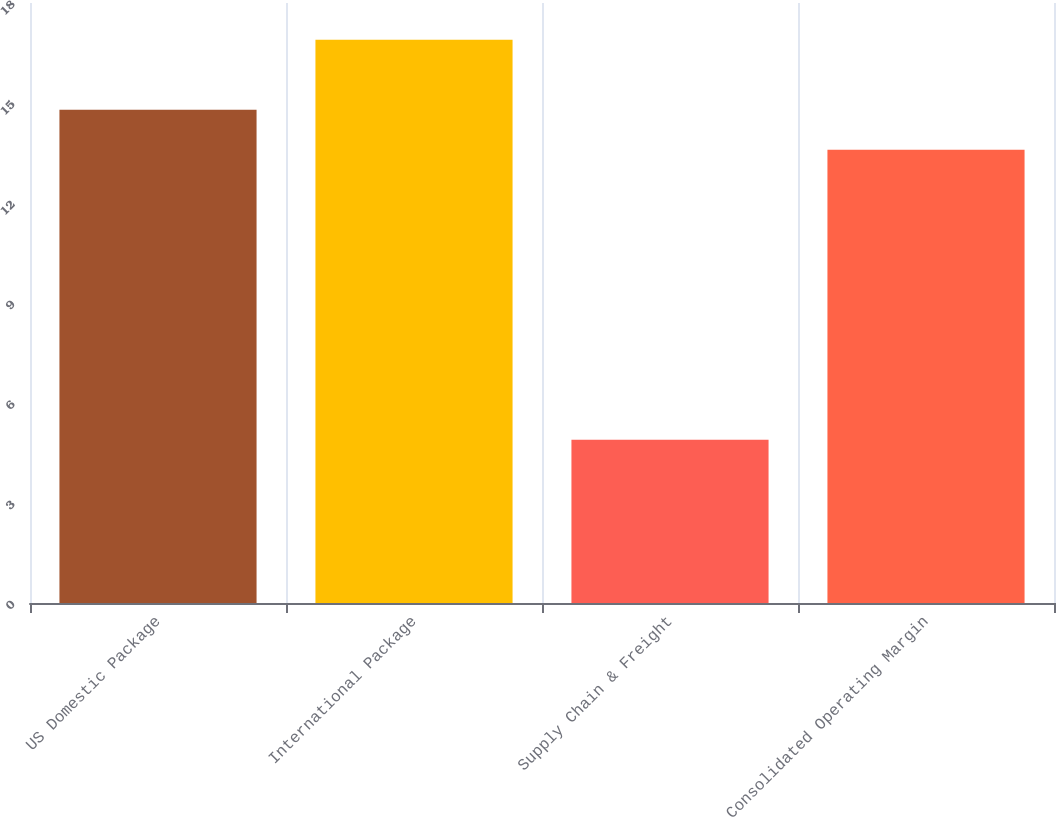Convert chart to OTSL. <chart><loc_0><loc_0><loc_500><loc_500><bar_chart><fcel>US Domestic Package<fcel>International Package<fcel>Supply Chain & Freight<fcel>Consolidated Operating Margin<nl><fcel>14.8<fcel>16.9<fcel>4.9<fcel>13.6<nl></chart> 